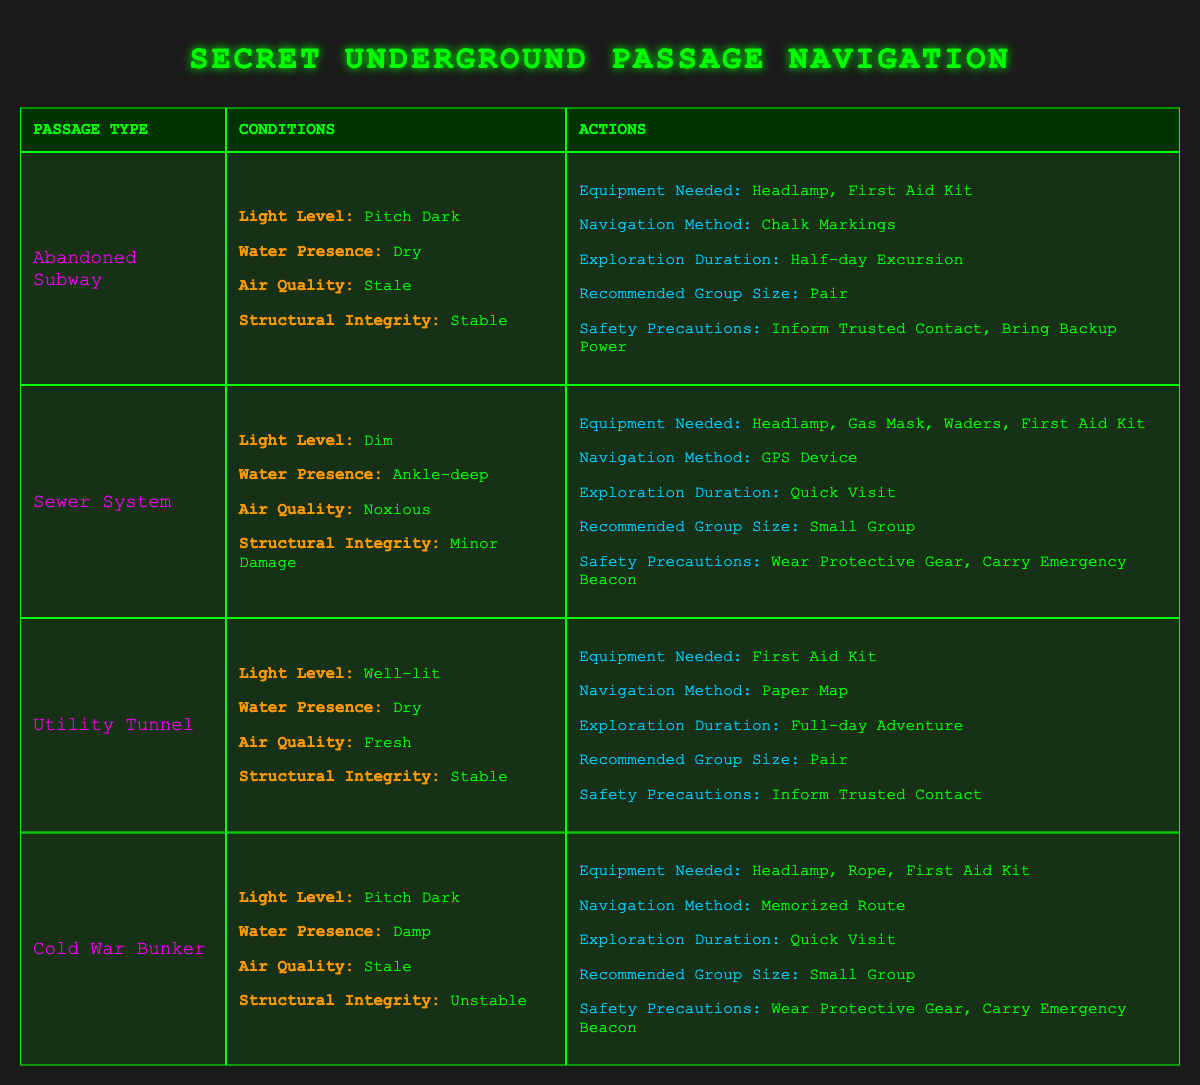What equipment is needed for exploring an Abandoned Subway? The table shows that for an Abandoned Subway with the specified conditions, the required equipment includes a Headlamp and a First Aid Kit.
Answer: Headlamp, First Aid Kit Which Navigation Method is recommended for a Sewer System? According to the table, the recommended Navigation Method for a Sewer System is a GPS Device, as outlined under the specific conditions detailed there.
Answer: GPS Device Is it safe to explore a Utility Tunnel with a pair of explorers? Yes, the table indicates that the recommended group size for exploring a Utility Tunnel is Pair, which suggests it is considered safe for two explorers.
Answer: Yes What is the Exploration Duration for a Cold War Bunker with specific conditions? The Cold War Bunker requires a Quick Visit according to the table, which indicates that it is not advisable to spend too much time there due to its unstable condition.
Answer: Quick Visit What are the safety precautions for exploring an Abandoned Subway? From the table, the safety precautions for an Abandoned Subway include informing a Trusted Contact and bringing Backup Power. This indicates the need for communication and additional safety measures while exploring.
Answer: Inform Trusted Contact, Bring Backup Power Calculate the total number of equipment options listed for exploring all passages. The passage types and corresponding equipment options are: Abandoned Subway (2), Sewer System (4), Utility Tunnel (1), Cold War Bunker (3). Summing these values gives 2 + 4 + 1 + 3 = 10 total equipment options across all passages.
Answer: 10 How many different types of recommended group sizes are there? The table lists three different recommended group sizes: Solo, Pair, and Small Group. This indicates a variety of group sizes outlined for exploration scenarios.
Answer: 3 If the air quality is Noxious, which passage can be explored? The only passage listed with Noxious air quality is the Sewer System, as detailed in the specific rules in the table. Therefore, this is the passage suitable for exploration under those air quality conditions.
Answer: Sewer System What is the recommended group size and equipment needed for exploring a Utility Tunnel? The recommended group size for exploring a Utility Tunnel is Pair, and the only equipment needed is a First Aid Kit, as per the table. This shows that it is a relatively straightforward exploration with fewer equipment demands.
Answer: Pair; First Aid Kit 